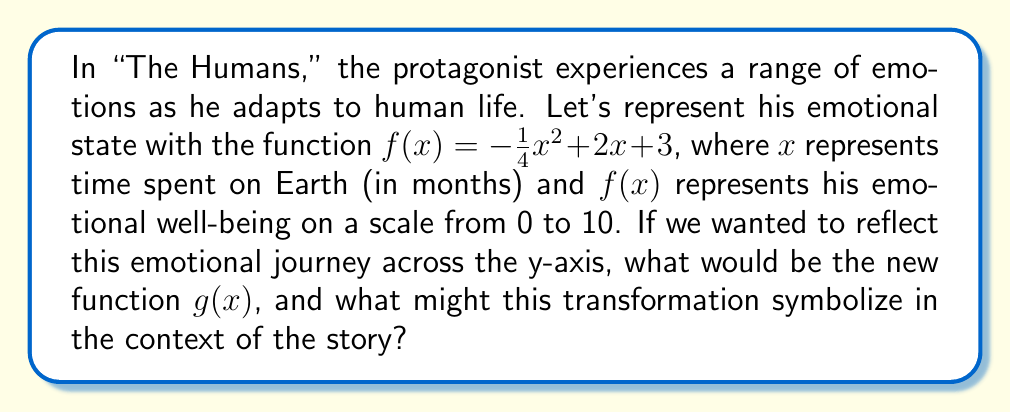Could you help me with this problem? To reflect the function $f(x) = -\frac{1}{4}x^2 + 2x + 3$ across the y-axis, we need to replace every $x$ in the original function with $-x$. This gives us:

$$g(x) = -\frac{1}{4}(-x)^2 + 2(-x) + 3$$

Let's simplify this step-by-step:

1) First, simplify $(-x)^2$:
   $(-x)^2 = x^2$ (because a negative squared becomes positive)

2) Now our function looks like:
   $$g(x) = -\frac{1}{4}x^2 - 2x + 3$$

3) The $x^2$ term remains unchanged, the linear term changes sign, and the constant term stays the same.

In the context of "The Humans," this reflection could symbolize an alternative emotional journey. While the original function might represent the protagonist's gradual understanding and appreciation of human life (increasing, then leveling off), the reflected function could represent a hypothetical scenario where he starts with a high appreciation of humanity that gradually decreases as he spends more time on Earth.

This transformation essentially reverses the protagonist's emotional trajectory along the x-axis, which could be interpreted as an exploration of "what if" scenarios in the story, or a commentary on how different initial perspectives can lead to vastly different emotional journeys.
Answer: $g(x) = -\frac{1}{4}x^2 - 2x + 3$ 